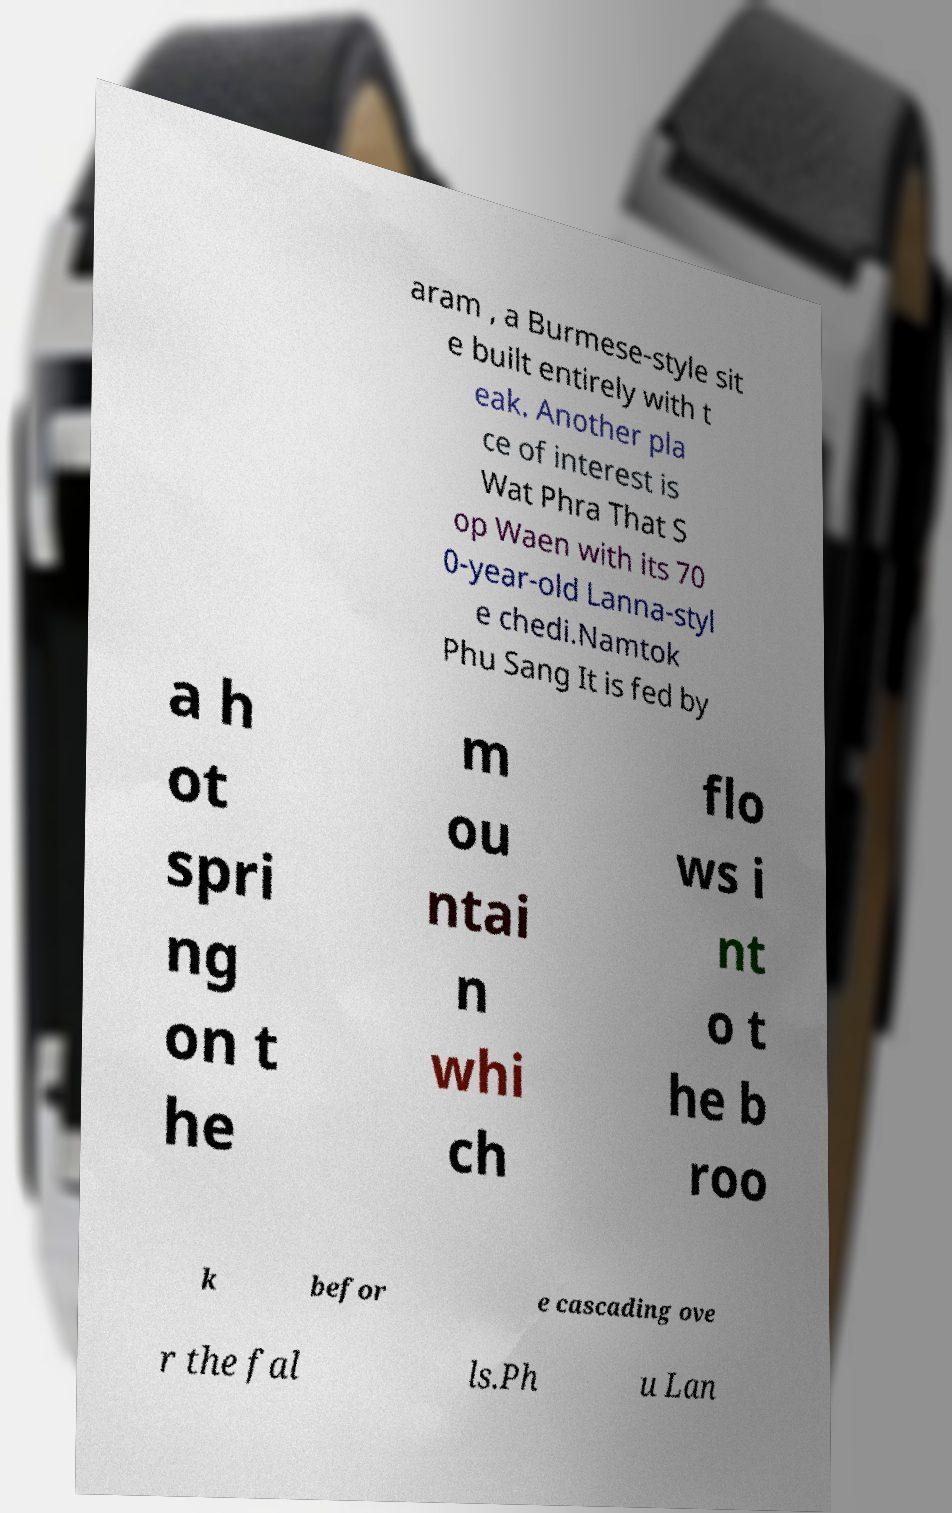What messages or text are displayed in this image? I need them in a readable, typed format. aram , a Burmese-style sit e built entirely with t eak. Another pla ce of interest is Wat Phra That S op Waen with its 70 0-year-old Lanna-styl e chedi.Namtok Phu Sang It is fed by a h ot spri ng on t he m ou ntai n whi ch flo ws i nt o t he b roo k befor e cascading ove r the fal ls.Ph u Lan 